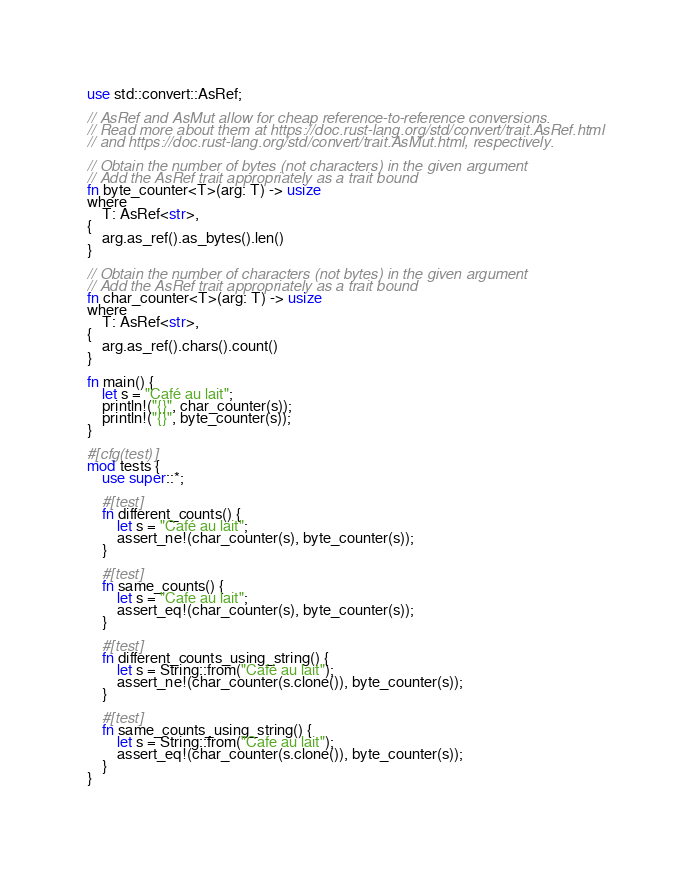Convert code to text. <code><loc_0><loc_0><loc_500><loc_500><_Rust_>use std::convert::AsRef;

// AsRef and AsMut allow for cheap reference-to-reference conversions.
// Read more about them at https://doc.rust-lang.org/std/convert/trait.AsRef.html
// and https://doc.rust-lang.org/std/convert/trait.AsMut.html, respectively.

// Obtain the number of bytes (not characters) in the given argument
// Add the AsRef trait appropriately as a trait bound
fn byte_counter<T>(arg: T) -> usize
where
    T: AsRef<str>,
{
    arg.as_ref().as_bytes().len()
}

// Obtain the number of characters (not bytes) in the given argument
// Add the AsRef trait appropriately as a trait bound
fn char_counter<T>(arg: T) -> usize
where
    T: AsRef<str>,
{
    arg.as_ref().chars().count()
}

fn main() {
    let s = "Café au lait";
    println!("{}", char_counter(s));
    println!("{}", byte_counter(s));
}

#[cfg(test)]
mod tests {
    use super::*;

    #[test]
    fn different_counts() {
        let s = "Café au lait";
        assert_ne!(char_counter(s), byte_counter(s));
    }

    #[test]
    fn same_counts() {
        let s = "Cafe au lait";
        assert_eq!(char_counter(s), byte_counter(s));
    }

    #[test]
    fn different_counts_using_string() {
        let s = String::from("Café au lait");
        assert_ne!(char_counter(s.clone()), byte_counter(s));
    }

    #[test]
    fn same_counts_using_string() {
        let s = String::from("Cafe au lait");
        assert_eq!(char_counter(s.clone()), byte_counter(s));
    }
}
</code> 